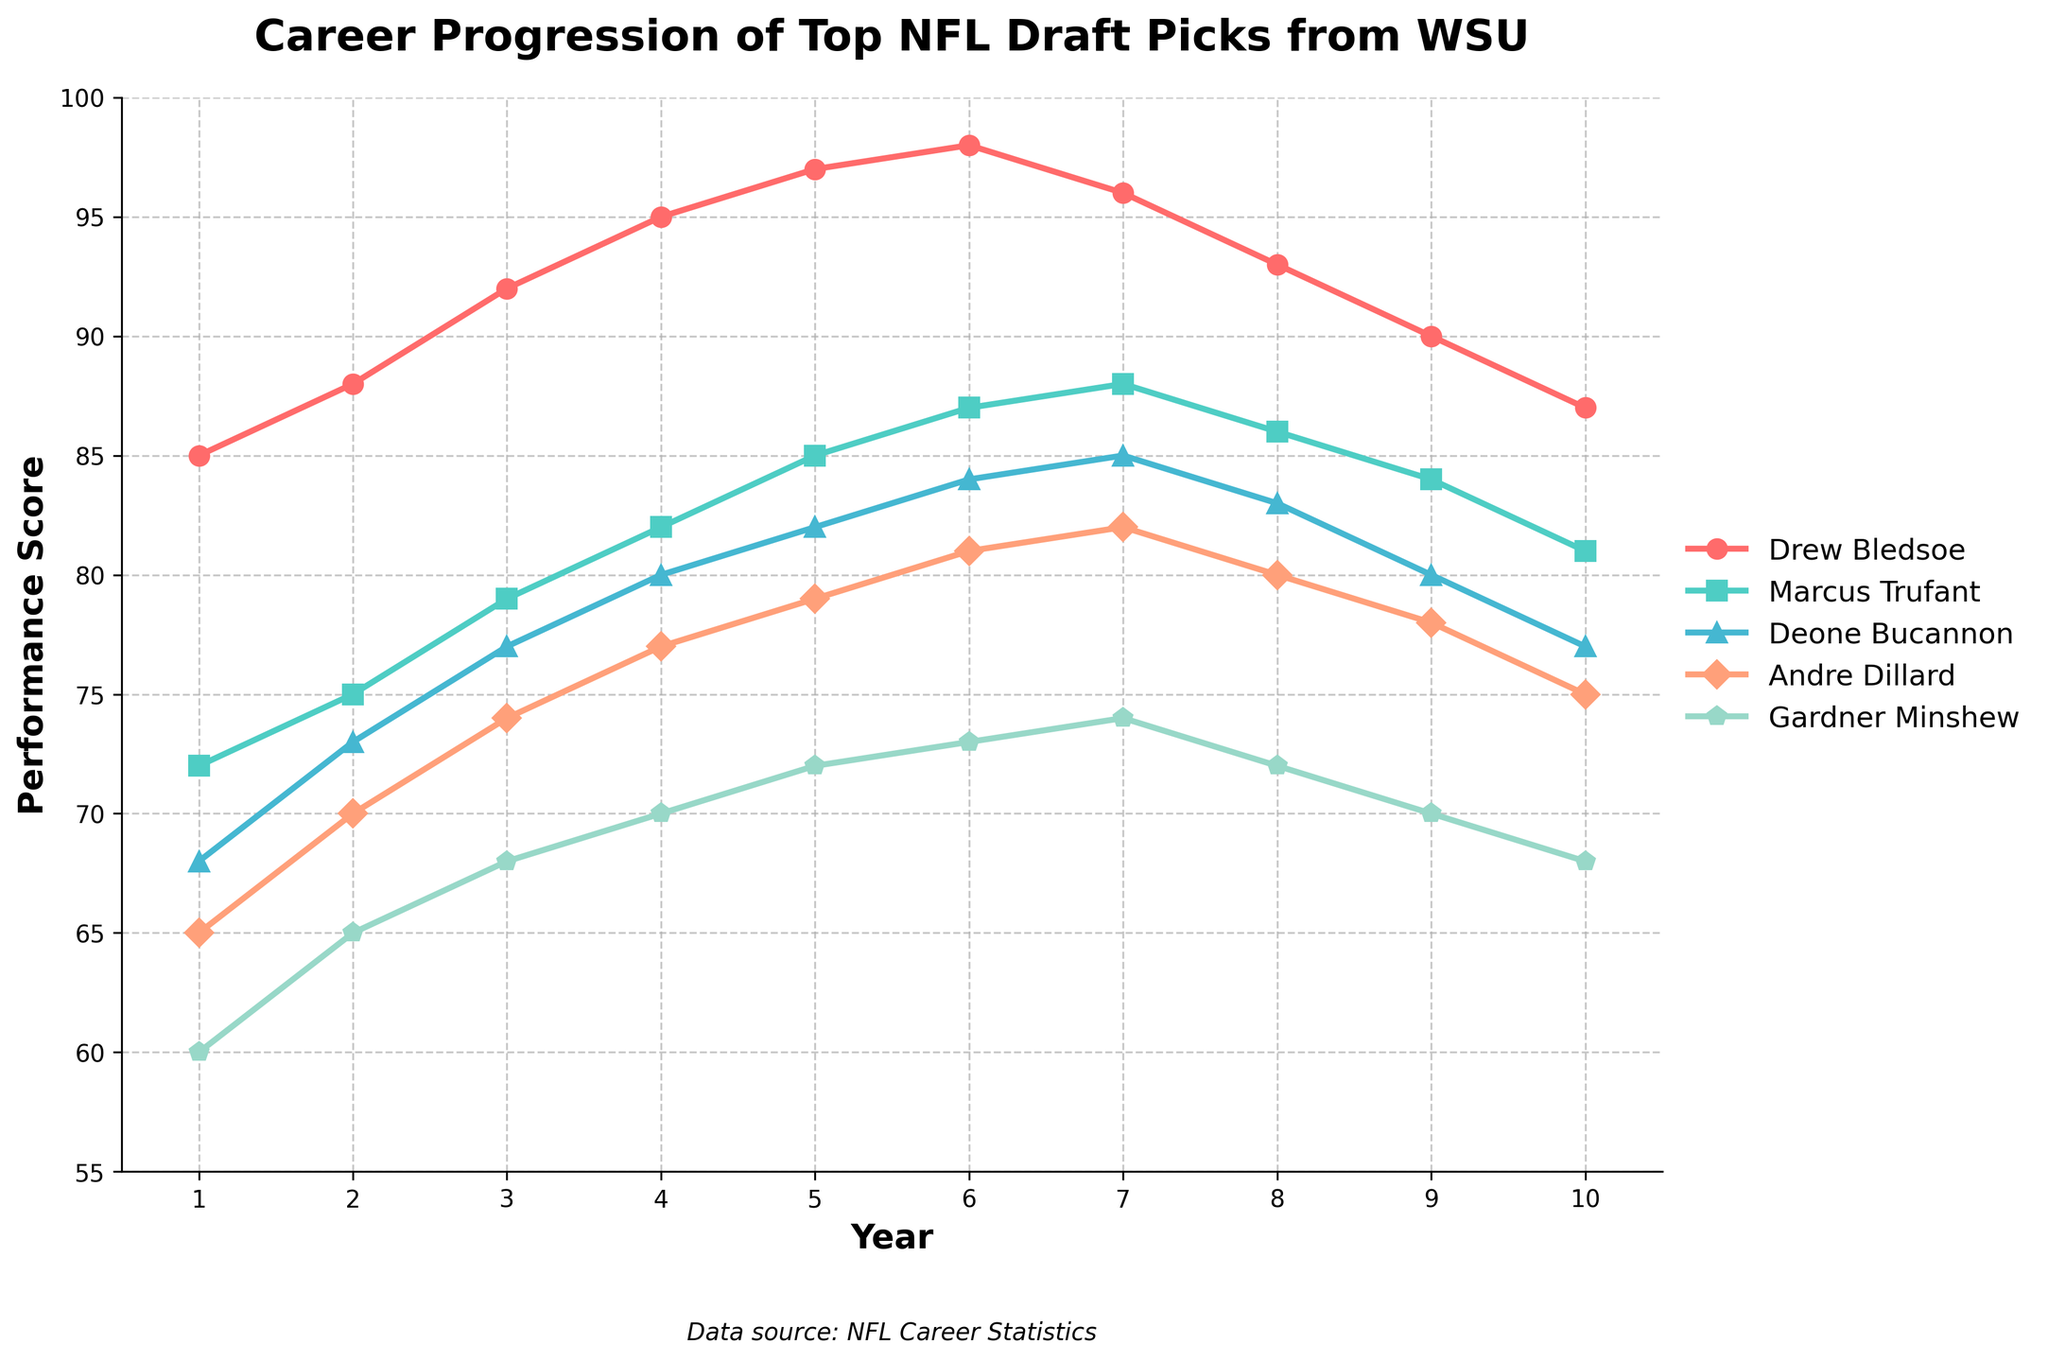What's the highest performance score achieved by any player in their first year? To find the highest performance score in the first year, look at the data points at Year 1 across all players. The highest value is for Drew Bledsoe, which is 85.
Answer: 85 Which player has the most consistent performance score over the 10 years? Consistency can be measured by the smallest variation in performance scores. Compare the range of performance scores for each player over the 10 years. Andre Dillard has the most consistent scores ranging from 65 to 81.
Answer: Andre Dillard Comparing Year 3, who has the highest performance score, and by how much does it exceed the lowest? To compare the highest and lowest scores in Year 3, observe the data points for all players in Year 3. Drew Bledsoe has the highest score with 92, and Gardner Minshew has the lowest score with 68. The difference is 92 - 68 = 24.
Answer: Drew Bledsoe, 24 From which year did Marcus Trufant's performance score remain consistently above 80? Observe Marcus Trufant's performance scores year by year. From Year 3 (79) to Year 4 (82) onwards, his performance remains consistently above 80.
Answer: Year 4 By the end of Year 10, which player's performance decreased the most from their peak performance, and by how much? Compare each player's maximum score and their score in Year 10. Calculate the difference:
- Drew Bledsoe's peak is 98, and Year 10 is 87: 98 - 87 = 11
- Marcus Trufant's peak is 88, and Year 10 is 81: 88 - 81 = 7
- Deone Bucannon's peak is 85, and Year 10 is 77: 85 - 77 = 8
- Andre Dillard's peak is 84, and Year 10 is 75: 84 - 75 = 9
- Gardner Minshew's peak is 74, and Year 10 is 68: 74 - 68 = 6
Drew Bledsoe has the most significant decrease of 11 points.
Answer: Drew Bledsoe, 11 Which year shows the maximum average performance score across all players? Calculate the average performance score for each year by summing the scores for all players and dividing by 5. Identify the maximum average:
- Year 1 = (85 + 72 + 68 + 65 + 60) / 5 = 70
- Year 2 = (88 + 75 + 73 + 70 + 65) / 5 = 74.2
- Year 3 = (92 + 79 + 77 + 74 + 68) / 5 = 78
- Year 4 = (95 + 82 + 80 + 77 + 70) / 5 = 80.8
- Year 5 = (97 + 85 + 82 + 79 + 72) / 5 = 83
- Year 6 = (98 + 87 + 84 + 81 + 73) / 5 = 84.6
- Year 7 = (96 + 88 + 85 + 82 + 74) / 5 = 85
- Year 8 = (93 + 86 + 83 + 80 + 72) / 5 = 82.8
- Year 9 = (90 + 84 + 80 + 78 + 70) / 5 = 80.4
- Year 10 = (87 + 81 + 77 + 75 + 68) / 5 = 77.6
Year 7 shows the maximum average performance score of 85.
Answer: Year 7 